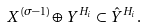Convert formula to latex. <formula><loc_0><loc_0><loc_500><loc_500>X ^ { ( \sigma - 1 ) } \oplus Y ^ { H _ { i } } \subset \hat { Y } ^ { H _ { i } } .</formula> 